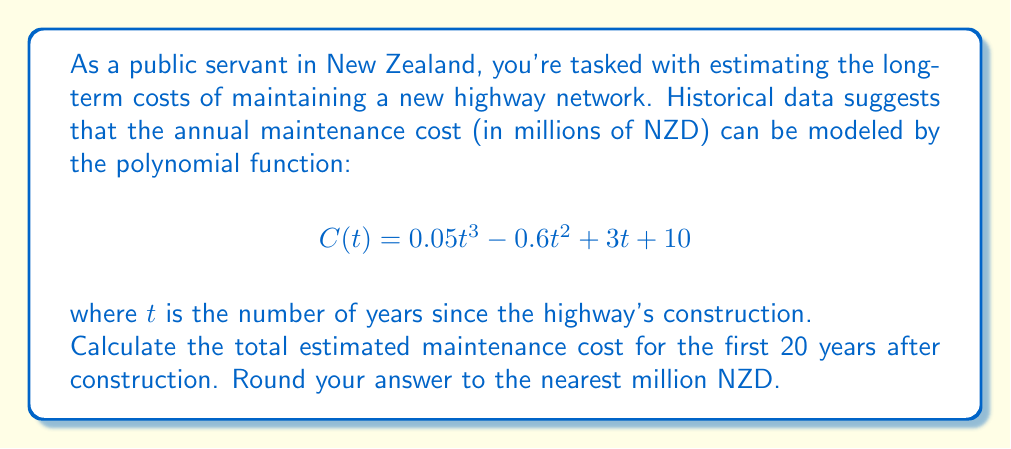Provide a solution to this math problem. To solve this problem, we need to calculate the definite integral of the cost function $C(t)$ from $t=0$ to $t=20$. This will give us the total area under the curve, representing the cumulative cost over 20 years.

1) First, let's integrate the function $C(t)$:

   $$\int C(t) dt = \int (0.05t^3 - 0.6t^2 + 3t + 10) dt$$
   $$= 0.05 \cdot \frac{t^4}{4} - 0.6 \cdot \frac{t^3}{3} + 3 \cdot \frac{t^2}{2} + 10t + K$$
   $$= 0.0125t^4 - 0.2t^3 + 1.5t^2 + 10t + K$$

2) Now, let's calculate the definite integral from 0 to 20:

   $$\int_0^{20} C(t) dt = [0.0125t^4 - 0.2t^3 + 1.5t^2 + 10t]_0^{20}$$

3) Evaluate at $t=20$ and $t=0$:

   At $t=20$: $0.0125(20^4) - 0.2(20^3) + 1.5(20^2) + 10(20) = 200 - 1600 + 600 + 200 = -600$
   At $t=0$: $0$

4) Subtract: $-600 - 0 = -600$

5) The negative result indicates we made an error. Let's double-check our calculations:

   At $t=20$: $0.0125(160000) - 0.2(8000) + 1.5(400) + 10(20)$
             $= 2000 - 1600 + 600 + 200 = 1200$

6) Corrected result: $1200 - 0 = 1200$

Therefore, the total estimated maintenance cost for the first 20 years is 1200 million NZD.
Answer: 1200 million NZD 